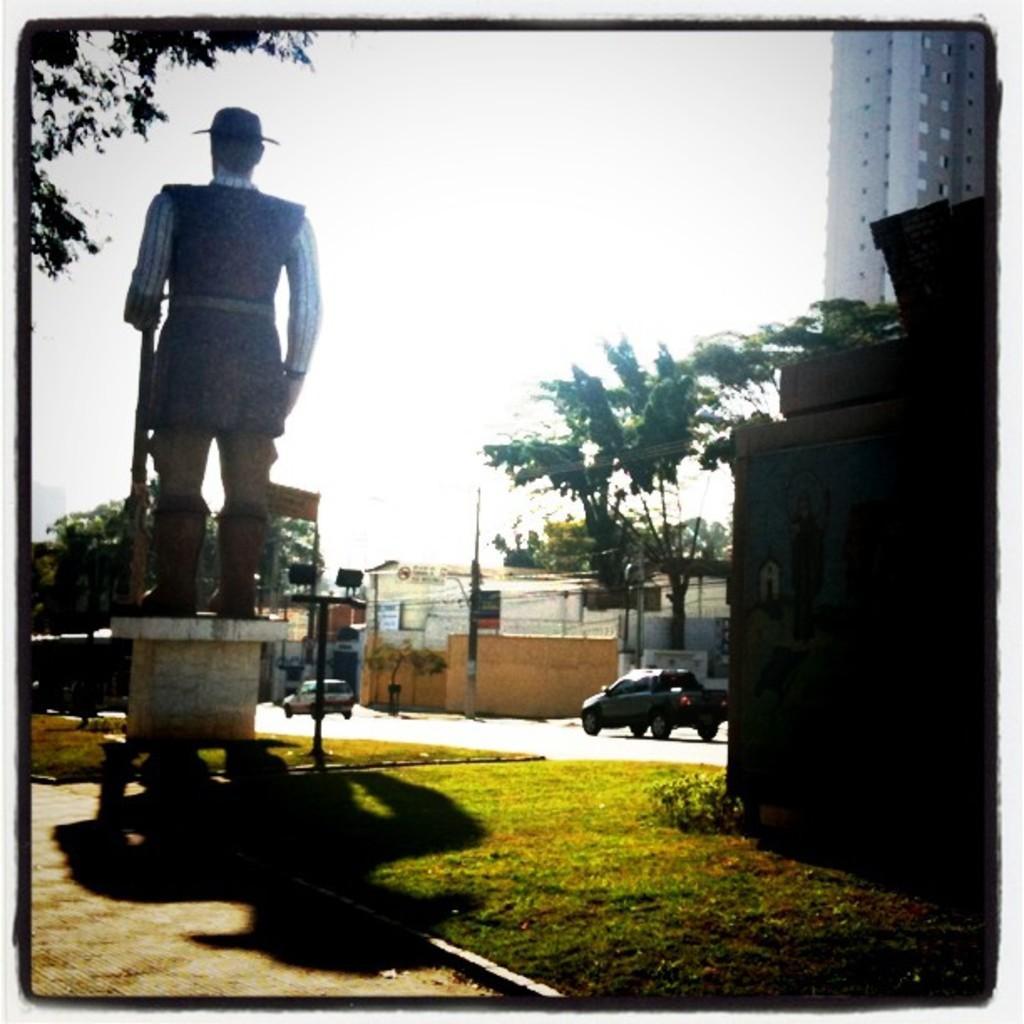How would you summarize this image in a sentence or two? In this image we can see a sculpture, trees, plants, grass, there are some buildings, vehicles on the road, and a board with some text written on it, also we can see the sky. 